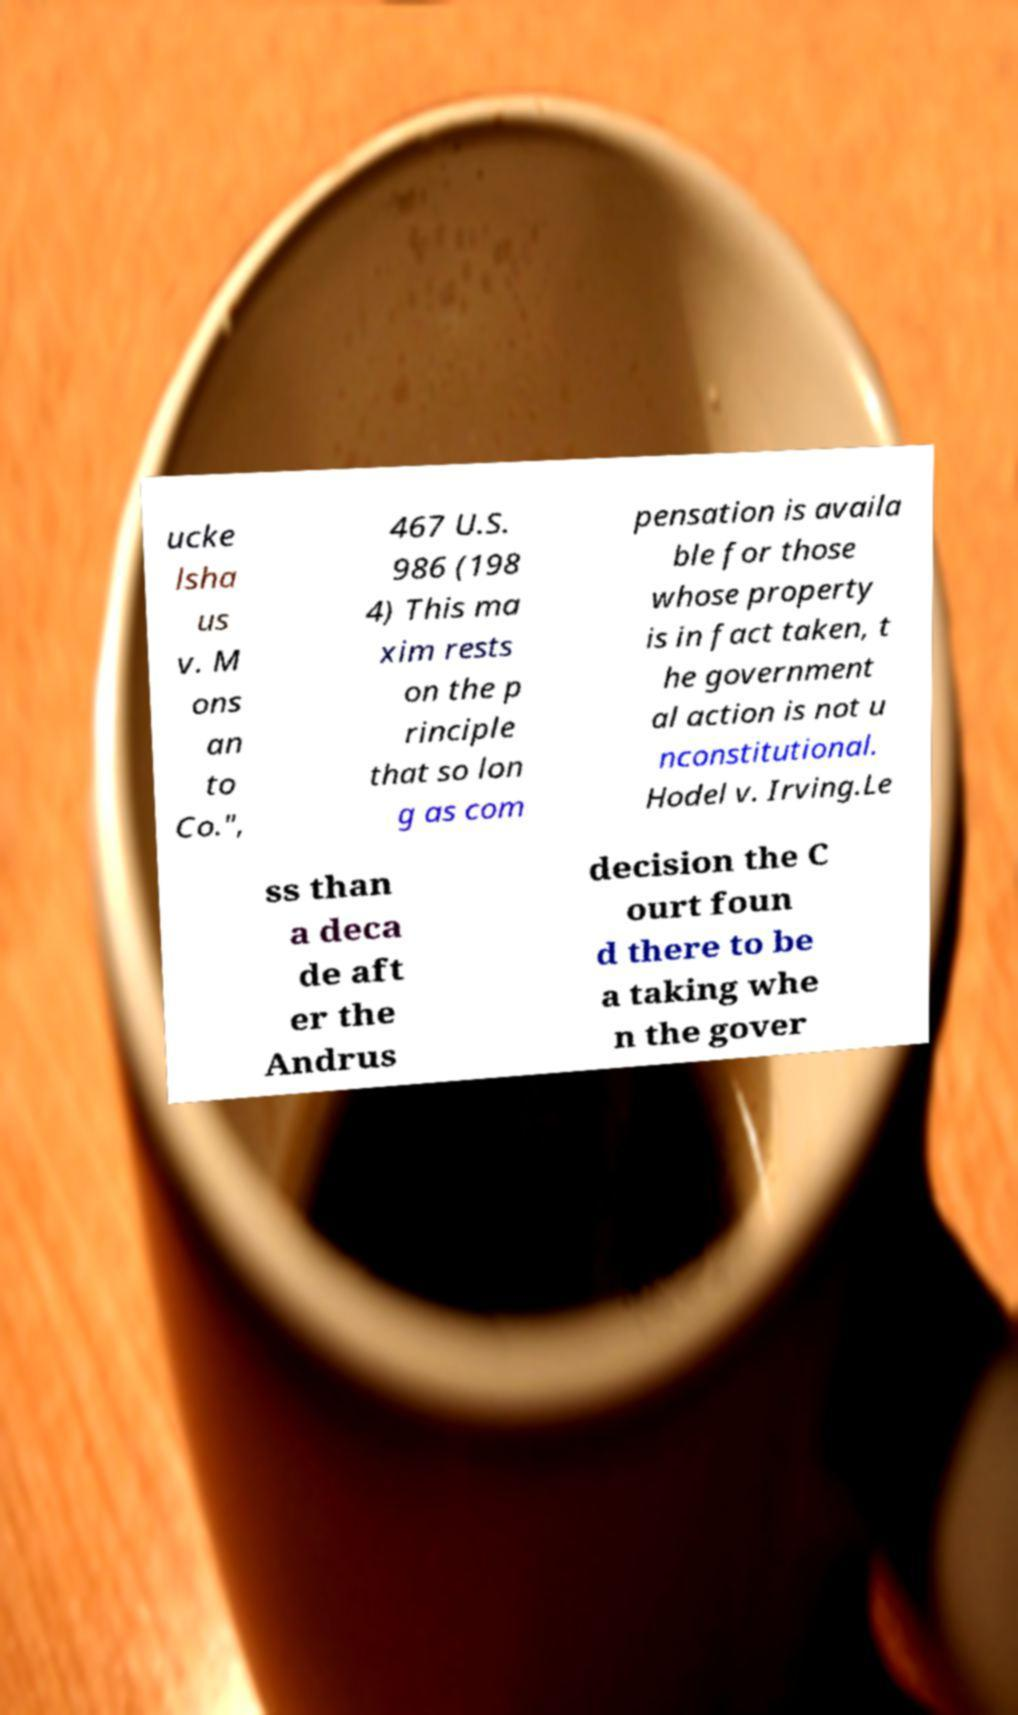Could you extract and type out the text from this image? ucke lsha us v. M ons an to Co.", 467 U.S. 986 (198 4) This ma xim rests on the p rinciple that so lon g as com pensation is availa ble for those whose property is in fact taken, t he government al action is not u nconstitutional. Hodel v. Irving.Le ss than a deca de aft er the Andrus decision the C ourt foun d there to be a taking whe n the gover 